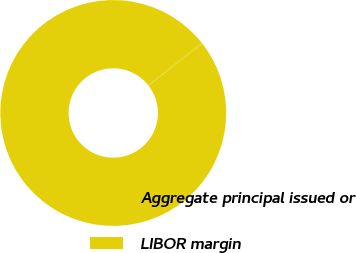<chart> <loc_0><loc_0><loc_500><loc_500><pie_chart><fcel>Aggregate principal issued or<fcel>LIBOR margin<nl><fcel>99.78%<fcel>0.22%<nl></chart> 